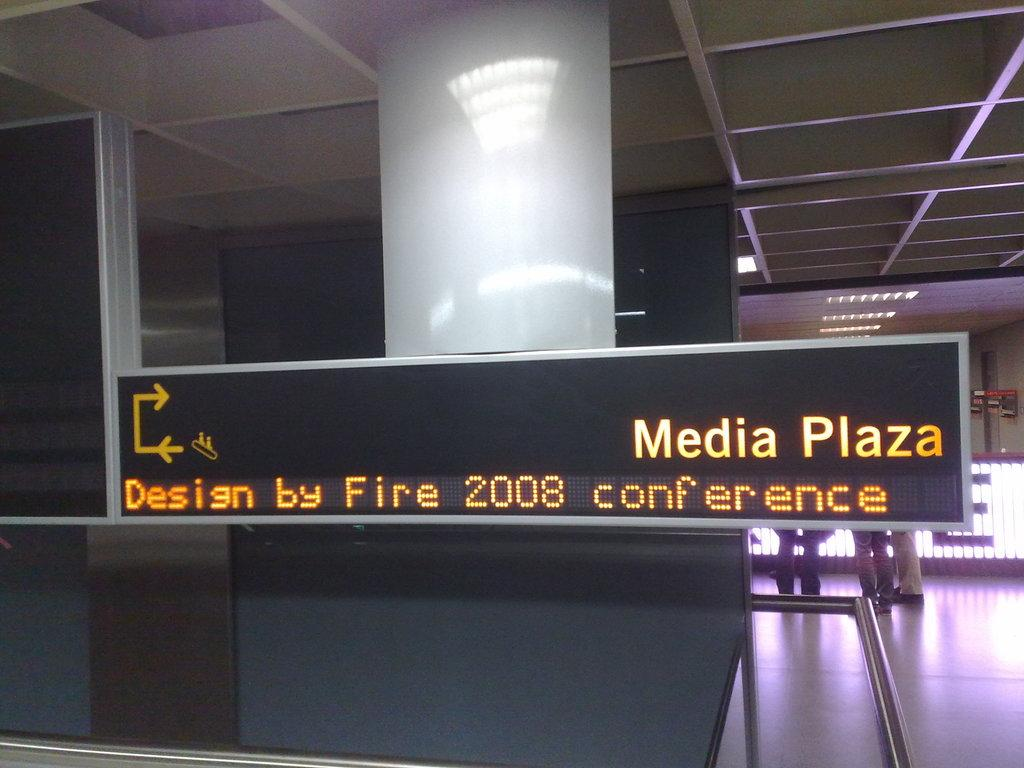<image>
Offer a succinct explanation of the picture presented. A sign at Media Plaza showing where the Design by Fire conference is in 2008. 